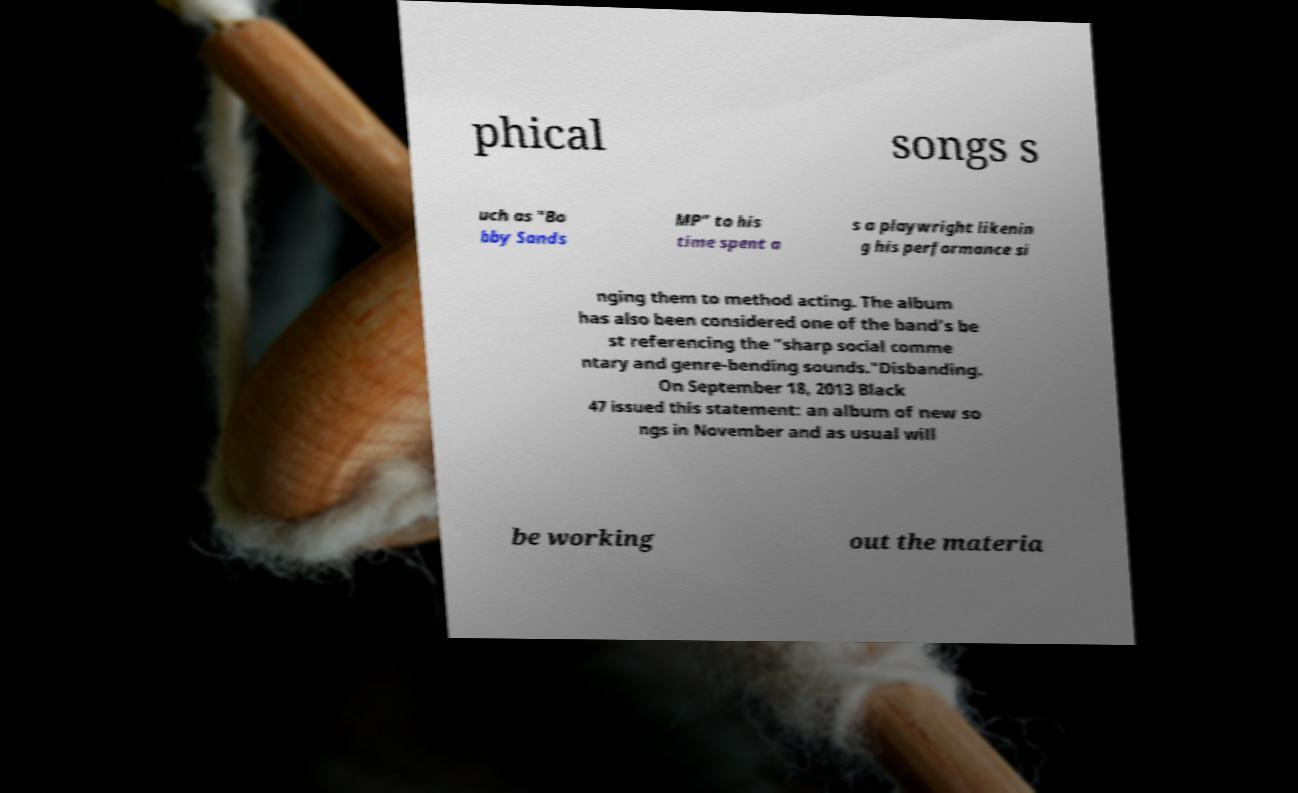Can you read and provide the text displayed in the image?This photo seems to have some interesting text. Can you extract and type it out for me? phical songs s uch as "Bo bby Sands MP" to his time spent a s a playwright likenin g his performance si nging them to method acting. The album has also been considered one of the band's be st referencing the "sharp social comme ntary and genre-bending sounds."Disbanding. On September 18, 2013 Black 47 issued this statement: an album of new so ngs in November and as usual will be working out the materia 